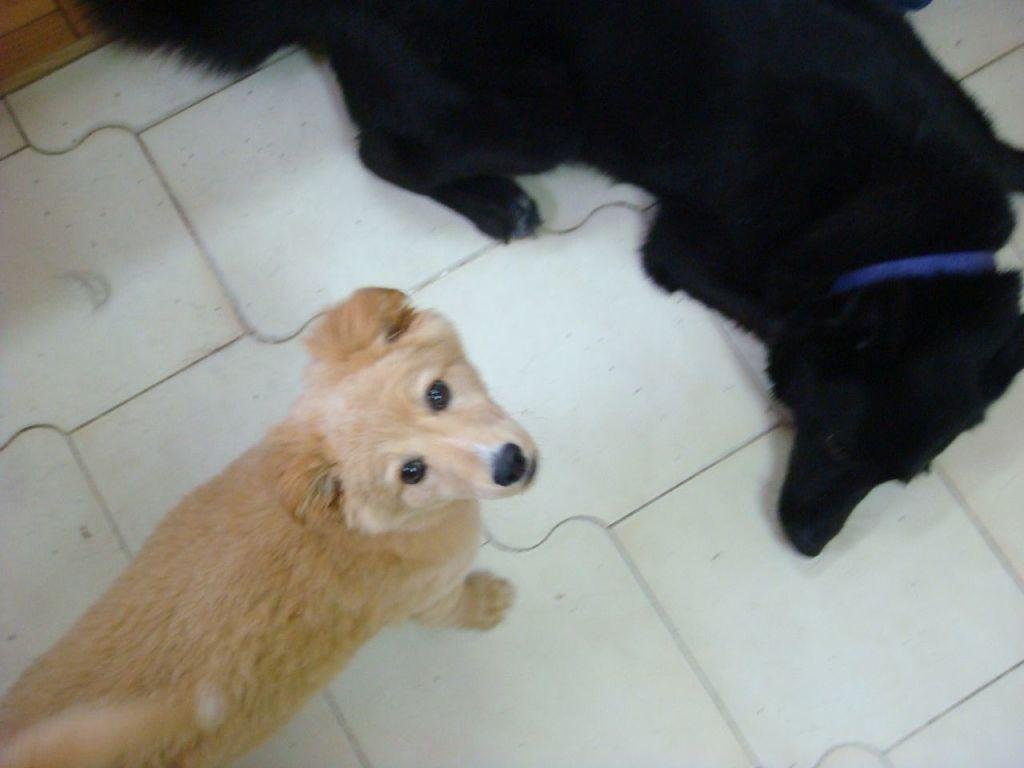How many dogs are present in the image? There are two dogs in the image. What are the colors of the dogs? One dog is black in color, and the other dog is brown in color. What is the position of the black dog in the image? The black dog is laying on the ground. What type of oil can be seen dripping from the brown dog in the image? There is no oil present in the image, and the brown dog is not depicted as dripping anything. 